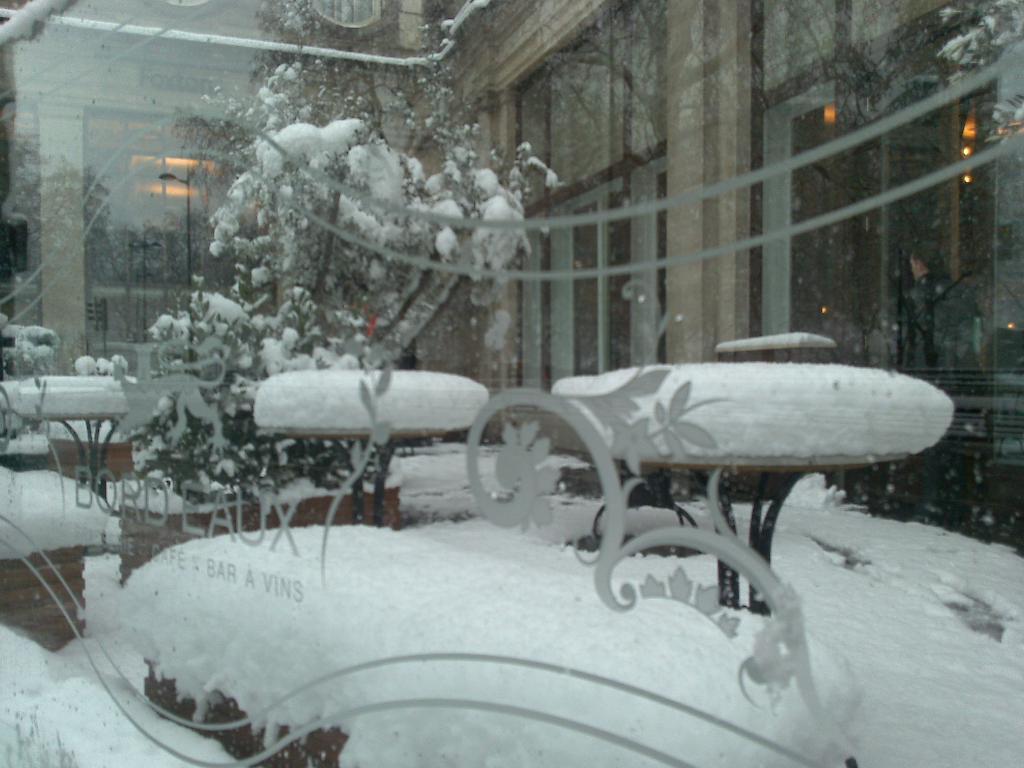How would you summarize this image in a sentence or two? In the foreground of the picture we can see a glass, on the glass there are some designs and text. In the middle of the picture we can see tables, benches, plant and snow. In the background it is looking like a building. 